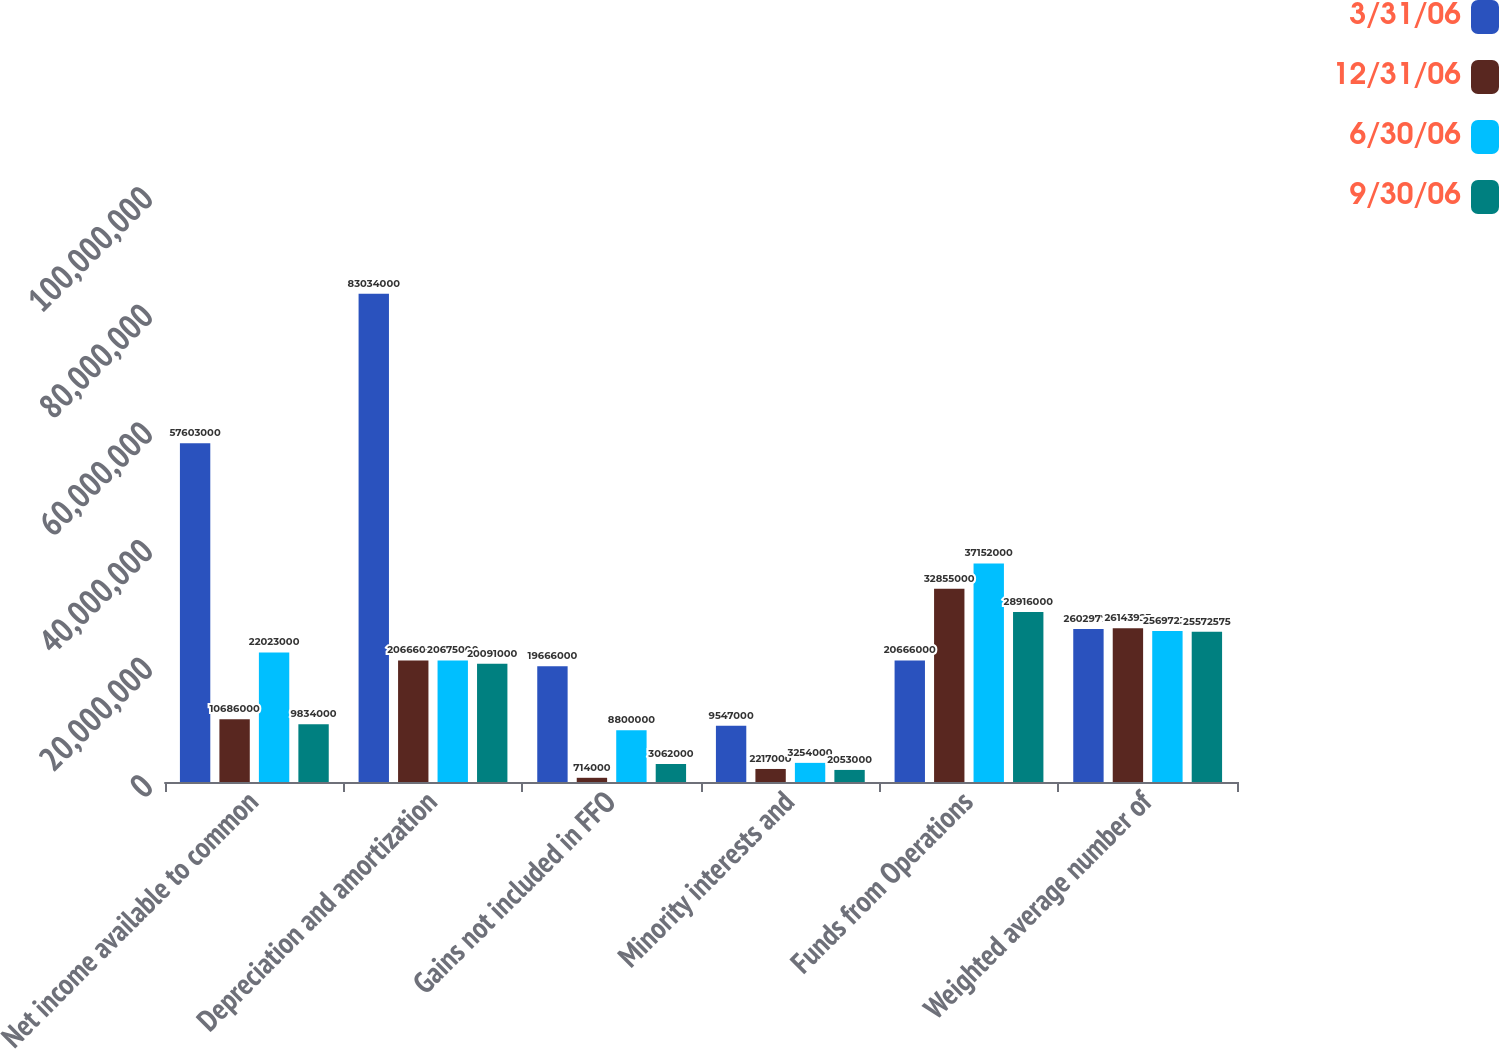Convert chart. <chart><loc_0><loc_0><loc_500><loc_500><stacked_bar_chart><ecel><fcel>Net income available to common<fcel>Depreciation and amortization<fcel>Gains not included in FFO<fcel>Minority interests and<fcel>Funds from Operations<fcel>Weighted average number of<nl><fcel>3/31/06<fcel>5.7603e+07<fcel>8.3034e+07<fcel>1.9666e+07<fcel>9.547e+06<fcel>2.0666e+07<fcel>2.60298e+07<nl><fcel>12/31/06<fcel>1.0686e+07<fcel>2.0666e+07<fcel>714000<fcel>2.217e+06<fcel>3.2855e+07<fcel>2.61439e+07<nl><fcel>6/30/06<fcel>2.2023e+07<fcel>2.0675e+07<fcel>8.8e+06<fcel>3.254e+06<fcel>3.7152e+07<fcel>2.56972e+07<nl><fcel>9/30/06<fcel>9.834e+06<fcel>2.0091e+07<fcel>3.062e+06<fcel>2.053e+06<fcel>2.8916e+07<fcel>2.55726e+07<nl></chart> 